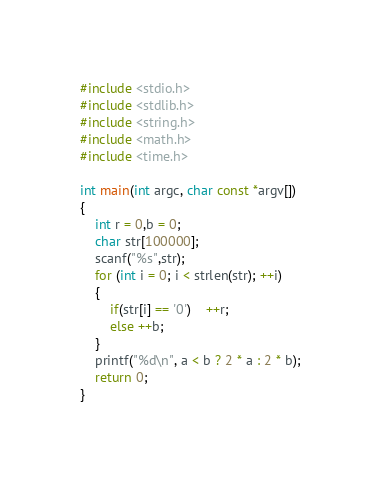<code> <loc_0><loc_0><loc_500><loc_500><_C_>#include <stdio.h>
#include <stdlib.h>
#include <string.h>
#include <math.h>
#include <time.h>

int main(int argc, char const *argv[])
{
	int r = 0,b = 0;
	char str[100000];
	scanf("%s",str);
	for (int i = 0; i < strlen(str); ++i)
	{
		if(str[i] == '0')	++r;
		else ++b;
	}
	printf("%d\n", a < b ? 2 * a : 2 * b);
	return 0;
}</code> 